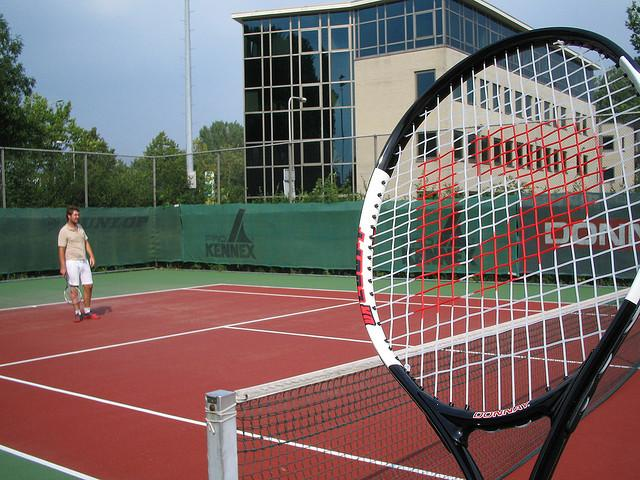Who plays this sport?

Choices:
A) serena williams
B) bo jackson
C) pele
D) marian hossa serena williams 